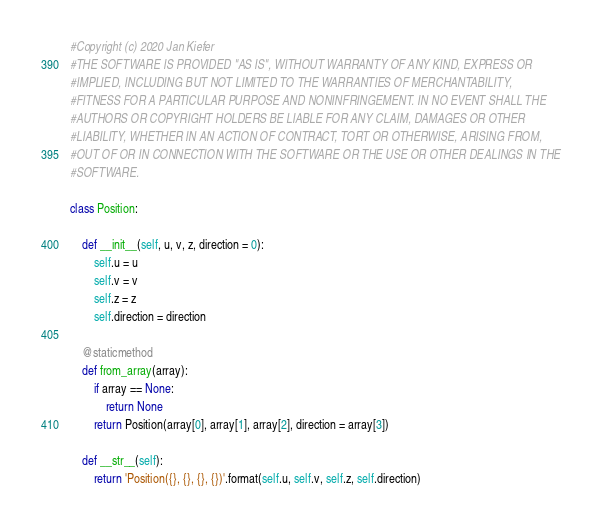<code> <loc_0><loc_0><loc_500><loc_500><_Python_>#Copyright (c) 2020 Jan Kiefer
#THE SOFTWARE IS PROVIDED "AS IS", WITHOUT WARRANTY OF ANY KIND, EXPRESS OR
#IMPLIED, INCLUDING BUT NOT LIMITED TO THE WARRANTIES OF MERCHANTABILITY,
#FITNESS FOR A PARTICULAR PURPOSE AND NONINFRINGEMENT. IN NO EVENT SHALL THE
#AUTHORS OR COPYRIGHT HOLDERS BE LIABLE FOR ANY CLAIM, DAMAGES OR OTHER
#LIABILITY, WHETHER IN AN ACTION OF CONTRACT, TORT OR OTHERWISE, ARISING FROM,
#OUT OF OR IN CONNECTION WITH THE SOFTWARE OR THE USE OR OTHER DEALINGS IN THE
#SOFTWARE.

class Position:
	
	def __init__(self, u, v, z, direction = 0):
		self.u = u
		self.v = v
		self.z = z
		self.direction = direction
	
	@staticmethod
	def from_array(array):
		if array == None:
			return None
		return Position(array[0], array[1], array[2], direction = array[3])
	
	def __str__(self):
		return 'Position({}, {}, {}, {})'.format(self.u, self.v, self.z, self.direction)</code> 